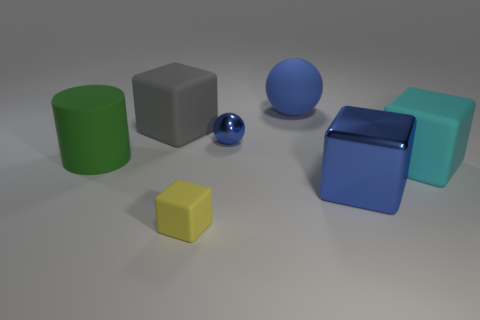There is a metallic object that is in front of the big cylinder; what is its color?
Your answer should be compact. Blue. The metal block that is the same size as the cyan thing is what color?
Your response must be concise. Blue. Do the matte cylinder and the matte ball have the same size?
Give a very brief answer. Yes. There is a small yellow matte object; how many green objects are left of it?
Your response must be concise. 1. What number of things are matte blocks that are to the right of the large blue matte thing or big things?
Your response must be concise. 5. Is the number of small yellow matte objects that are in front of the small yellow matte block greater than the number of large rubber cylinders that are behind the small blue thing?
Make the answer very short. No. What is the size of the metal cube that is the same color as the metallic sphere?
Keep it short and to the point. Large. Is the size of the cyan cube the same as the cube that is behind the big cyan rubber block?
Provide a succinct answer. Yes. How many balls are either green things or cyan matte objects?
Your answer should be compact. 0. The object that is made of the same material as the blue block is what size?
Give a very brief answer. Small. 